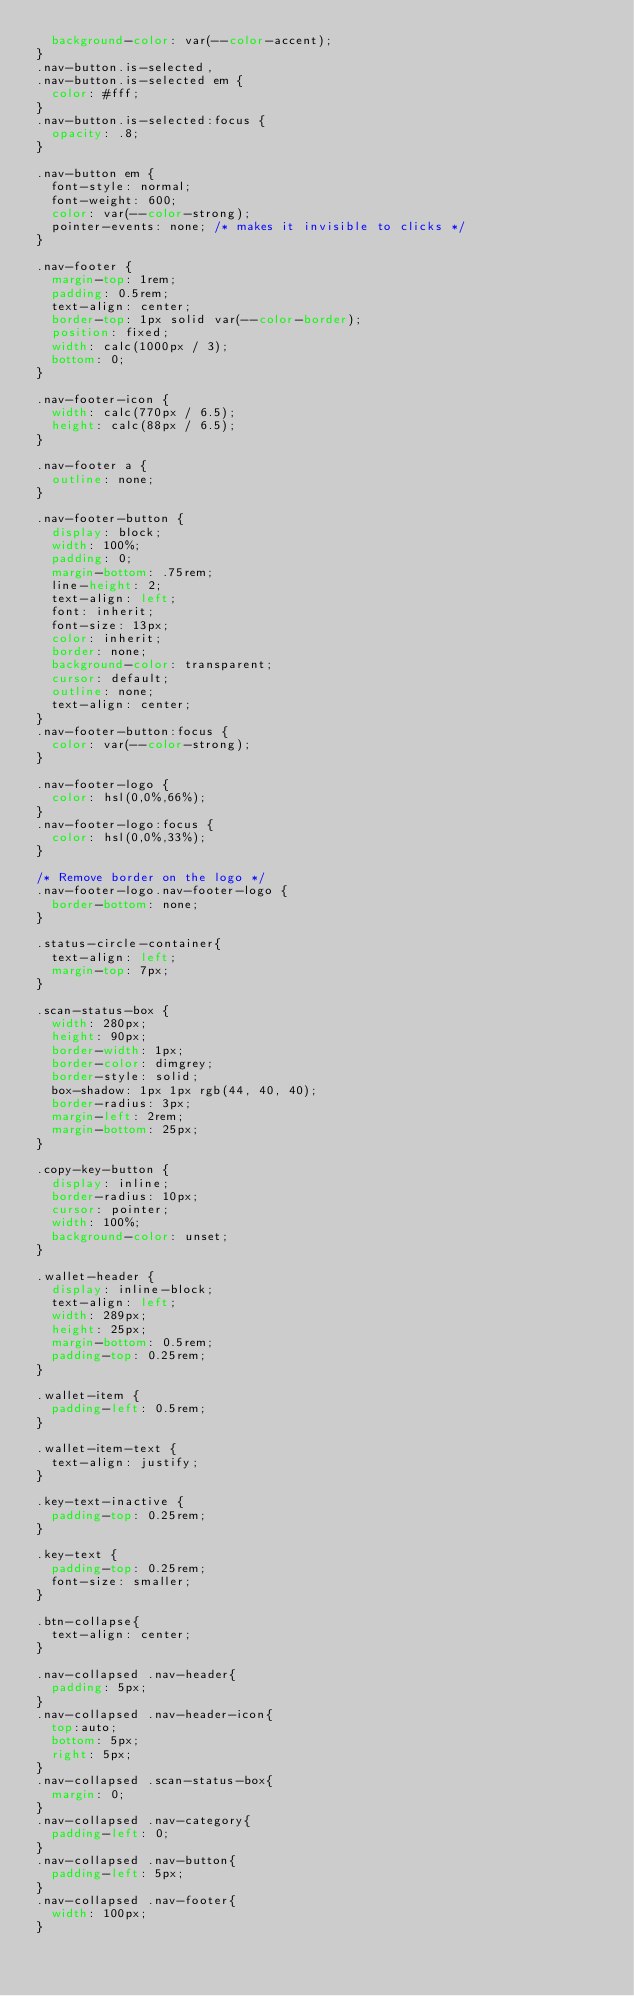Convert code to text. <code><loc_0><loc_0><loc_500><loc_500><_CSS_>  background-color: var(--color-accent);
}
.nav-button.is-selected,
.nav-button.is-selected em {
  color: #fff;
}
.nav-button.is-selected:focus {
  opacity: .8;
}

.nav-button em {
  font-style: normal;
  font-weight: 600;
  color: var(--color-strong);
  pointer-events: none; /* makes it invisible to clicks */
}

.nav-footer {
  margin-top: 1rem;
  padding: 0.5rem;
  text-align: center;
  border-top: 1px solid var(--color-border);
  position: fixed;
  width: calc(1000px / 3);
  bottom: 0;
}

.nav-footer-icon {
  width: calc(770px / 6.5);
  height: calc(88px / 6.5);
}

.nav-footer a {
  outline: none;
}

.nav-footer-button {
  display: block;
  width: 100%;
  padding: 0;
  margin-bottom: .75rem;
  line-height: 2;
  text-align: left;
  font: inherit;
  font-size: 13px;
  color: inherit;
  border: none;
  background-color: transparent;
  cursor: default;
  outline: none;
  text-align: center;
}
.nav-footer-button:focus {
  color: var(--color-strong);
}

.nav-footer-logo {
  color: hsl(0,0%,66%);
}
.nav-footer-logo:focus {
  color: hsl(0,0%,33%);
}

/* Remove border on the logo */
.nav-footer-logo.nav-footer-logo {
  border-bottom: none;
}

.status-circle-container{
  text-align: left;
  margin-top: 7px;
}

.scan-status-box {
  width: 280px;
  height: 90px;
  border-width: 1px;
  border-color: dimgrey;
  border-style: solid;
  box-shadow: 1px 1px rgb(44, 40, 40);
  border-radius: 3px;
  margin-left: 2rem;
  margin-bottom: 25px;
}

.copy-key-button {
  display: inline;
  border-radius: 10px;
  cursor: pointer;
  width: 100%;
  background-color: unset;
}

.wallet-header {
  display: inline-block;
  text-align: left;
  width: 289px;
  height: 25px;
  margin-bottom: 0.5rem;
  padding-top: 0.25rem;
}

.wallet-item {
  padding-left: 0.5rem;
}

.wallet-item-text {
  text-align: justify;
}

.key-text-inactive {
  padding-top: 0.25rem;
}

.key-text {
  padding-top: 0.25rem;
  font-size: smaller;
}

.btn-collapse{
  text-align: center;
}

.nav-collapsed .nav-header{
  padding: 5px;
}
.nav-collapsed .nav-header-icon{
  top:auto;
  bottom: 5px;
  right: 5px;
}
.nav-collapsed .scan-status-box{
  margin: 0;
}
.nav-collapsed .nav-category{
  padding-left: 0;
}
.nav-collapsed .nav-button{
  padding-left: 5px;
}
.nav-collapsed .nav-footer{
  width: 100px;
}</code> 